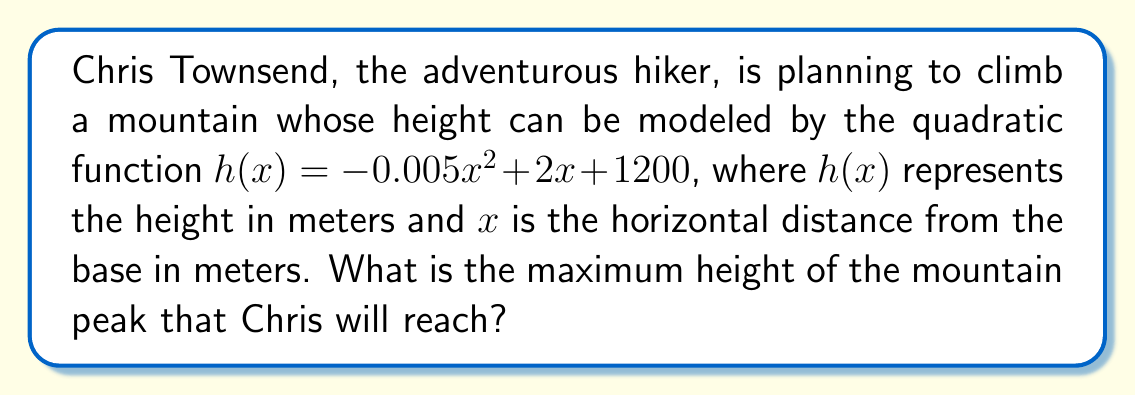Can you answer this question? To find the maximum height of the mountain peak, we need to determine the vertex of the quadratic function. The vertex represents the highest point of the parabola, which corresponds to the peak of the mountain.

Given the quadratic function: $h(x) = -0.005x^2 + 2x + 1200$

1. For a quadratic function in the form $f(x) = ax^2 + bx + c$, the x-coordinate of the vertex is given by $x = -\frac{b}{2a}$.

2. In this case, $a = -0.005$ and $b = 2$. Let's calculate the x-coordinate of the vertex:

   $x = -\frac{b}{2a} = -\frac{2}{2(-0.005)} = -\frac{2}{-0.01} = 200$

3. To find the maximum height, we need to substitute this x-value back into the original function:

   $h(200) = -0.005(200)^2 + 2(200) + 1200$
   
   $= -0.005(40000) + 400 + 1200$
   
   $= -200 + 400 + 1200$
   
   $= 1400$

Therefore, the maximum height of the mountain peak is 1400 meters.
Answer: The maximum height of the mountain peak that Chris Townsend will reach is 1400 meters. 